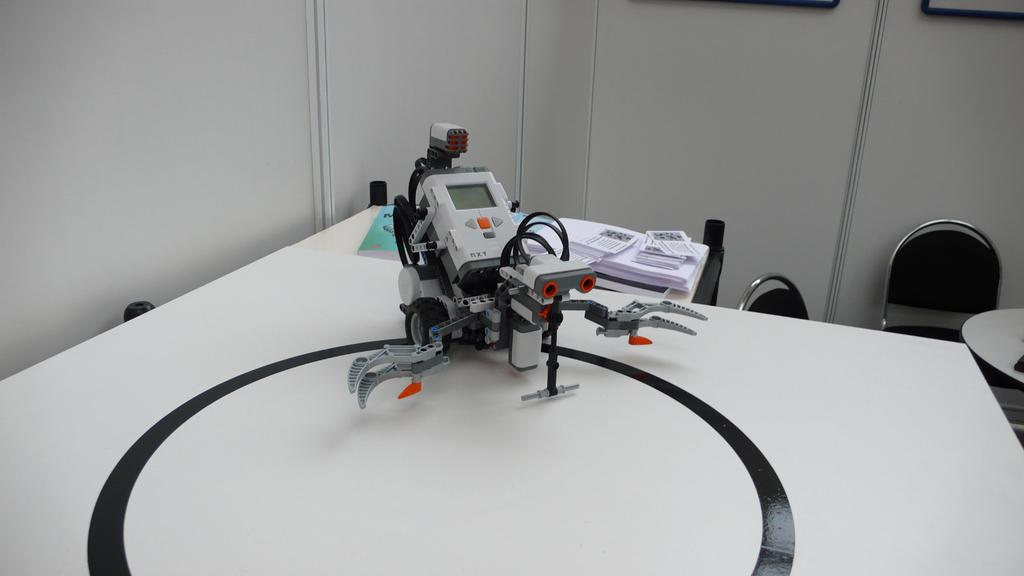What is the main subject in the image? There is a robot in the image. Where is the robot located? The robot is on a table. What color is the table? The table is white. What can be seen in the background of the image? There is a wall in the background of the image. What color is the wall? The wall is white. How many chairs are in the image? There are two chairs in the image. How does the robot behave when it encounters a road in the image? There is no road present in the image, so the robot's behavior in that situation cannot be determined. 